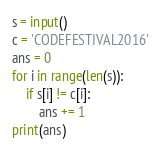Convert code to text. <code><loc_0><loc_0><loc_500><loc_500><_Python_>s = input()
c = 'CODEFESTIVAL2016'
ans = 0
for i in range(len(s)):
    if s[i] != c[i]:
        ans += 1
print(ans)</code> 